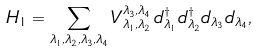<formula> <loc_0><loc_0><loc_500><loc_500>H _ { 1 } = \sum _ { \lambda _ { 1 } , \lambda _ { 2 } , \lambda _ { 3 } , \lambda _ { 4 } } V _ { \lambda _ { 1 } , \lambda _ { 2 } } ^ { \lambda _ { 3 } , \lambda _ { 4 } } \, d _ { \lambda _ { 1 } } ^ { \dagger } d _ { \lambda _ { 2 } } ^ { \dagger } d _ { \lambda _ { 3 } } d _ { \lambda _ { 4 } } ,</formula> 